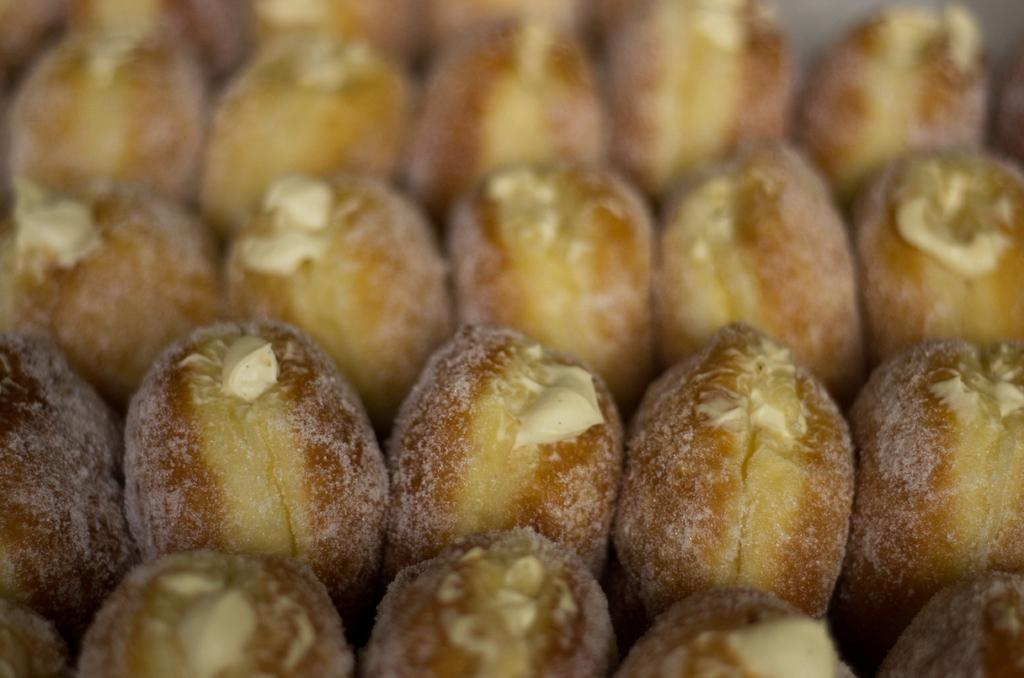What type of items can be seen in the image? The image contains food. What type of good-bye message can be seen written on the food in the image? There is no good-bye message present on the food in the image. What type of bean is visible in the image? There is no bean present in the image. 